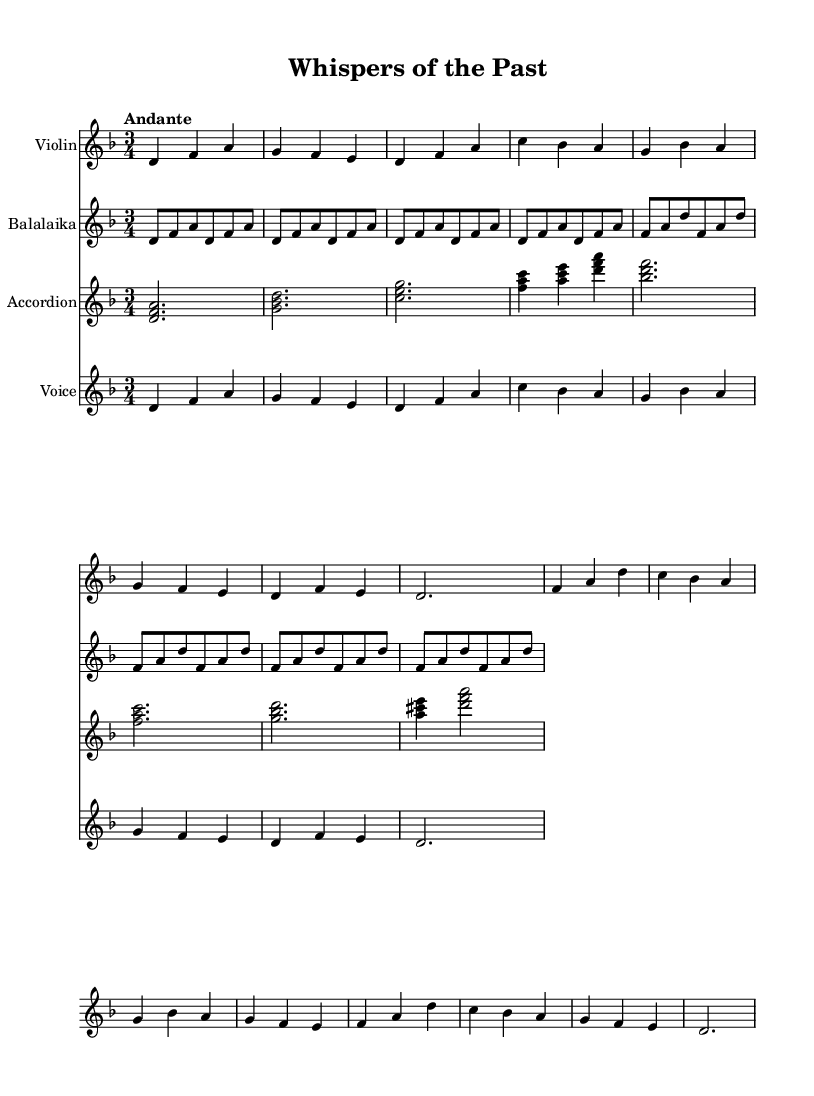What is the key signature of this music? The key signature shows two flats, which indicates that the music is in D minor.
Answer: D minor What is the time signature of this music? The time signature is indicated at the beginning and shows a "3/4," meaning there are three beats in each measure.
Answer: 3/4 What is the tempo marking for this piece? The tempo marking is "Andante," which suggests a moderate pace.
Answer: Andante How many measures are there in the verse section? By counting the measures in the verse, we see there are eight measures total.
Answer: Eight What are the dynamics indicated for the chorus section? The sheet music did not indicate specific dynamics, which means it is up to the performer to interpret it, typically performed with expressive dynamics.
Answer: Expressive What emotion or theme do the lyrics of this song convey? The lyrics reflect nostalgia and a longing for the past, as they mention hidden stories and memories tied to Mother Russia.
Answer: Nostalgia Which instruments are featured in this arrangement? The arrangement includes violin, balalaika, accordion, and voice, providing a rich texture typical of folk music.
Answer: Violin, balalaika, accordion, voice 